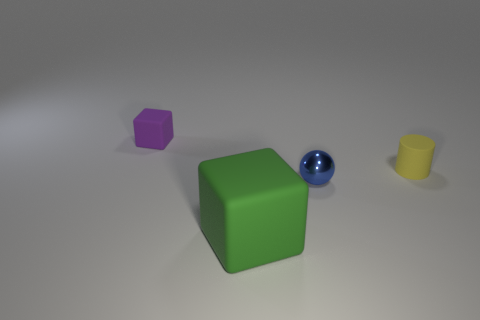Add 3 small rubber balls. How many objects exist? 7 Subtract all spheres. How many objects are left? 3 Subtract 0 red cubes. How many objects are left? 4 Subtract all small blue objects. Subtract all big blocks. How many objects are left? 2 Add 2 green cubes. How many green cubes are left? 3 Add 2 blue rubber cylinders. How many blue rubber cylinders exist? 2 